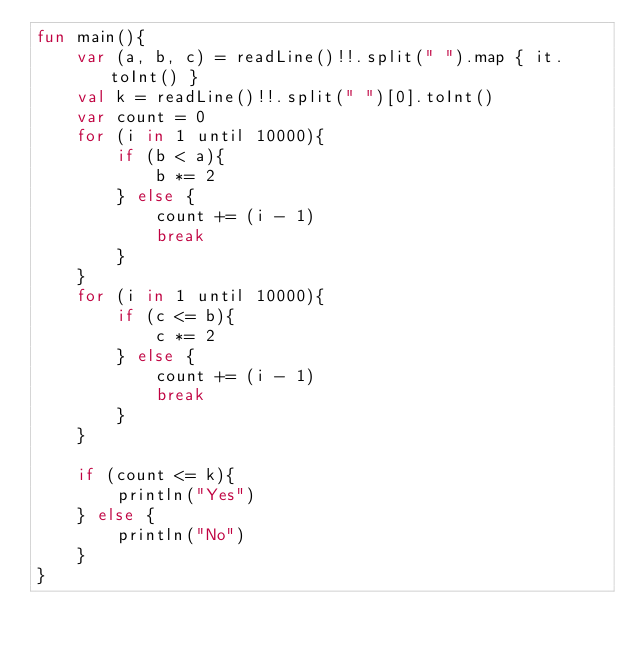<code> <loc_0><loc_0><loc_500><loc_500><_Kotlin_>fun main(){
    var (a, b, c) = readLine()!!.split(" ").map { it.toInt() }
    val k = readLine()!!.split(" ")[0].toInt()
    var count = 0
    for (i in 1 until 10000){
        if (b < a){
            b *= 2
        } else {
            count += (i - 1)
            break
        }
    }
    for (i in 1 until 10000){
        if (c <= b){
            c *= 2
        } else {
            count += (i - 1)
            break
        }
    }
    
    if (count <= k){
        println("Yes")
    } else {
        println("No")
    }
}</code> 